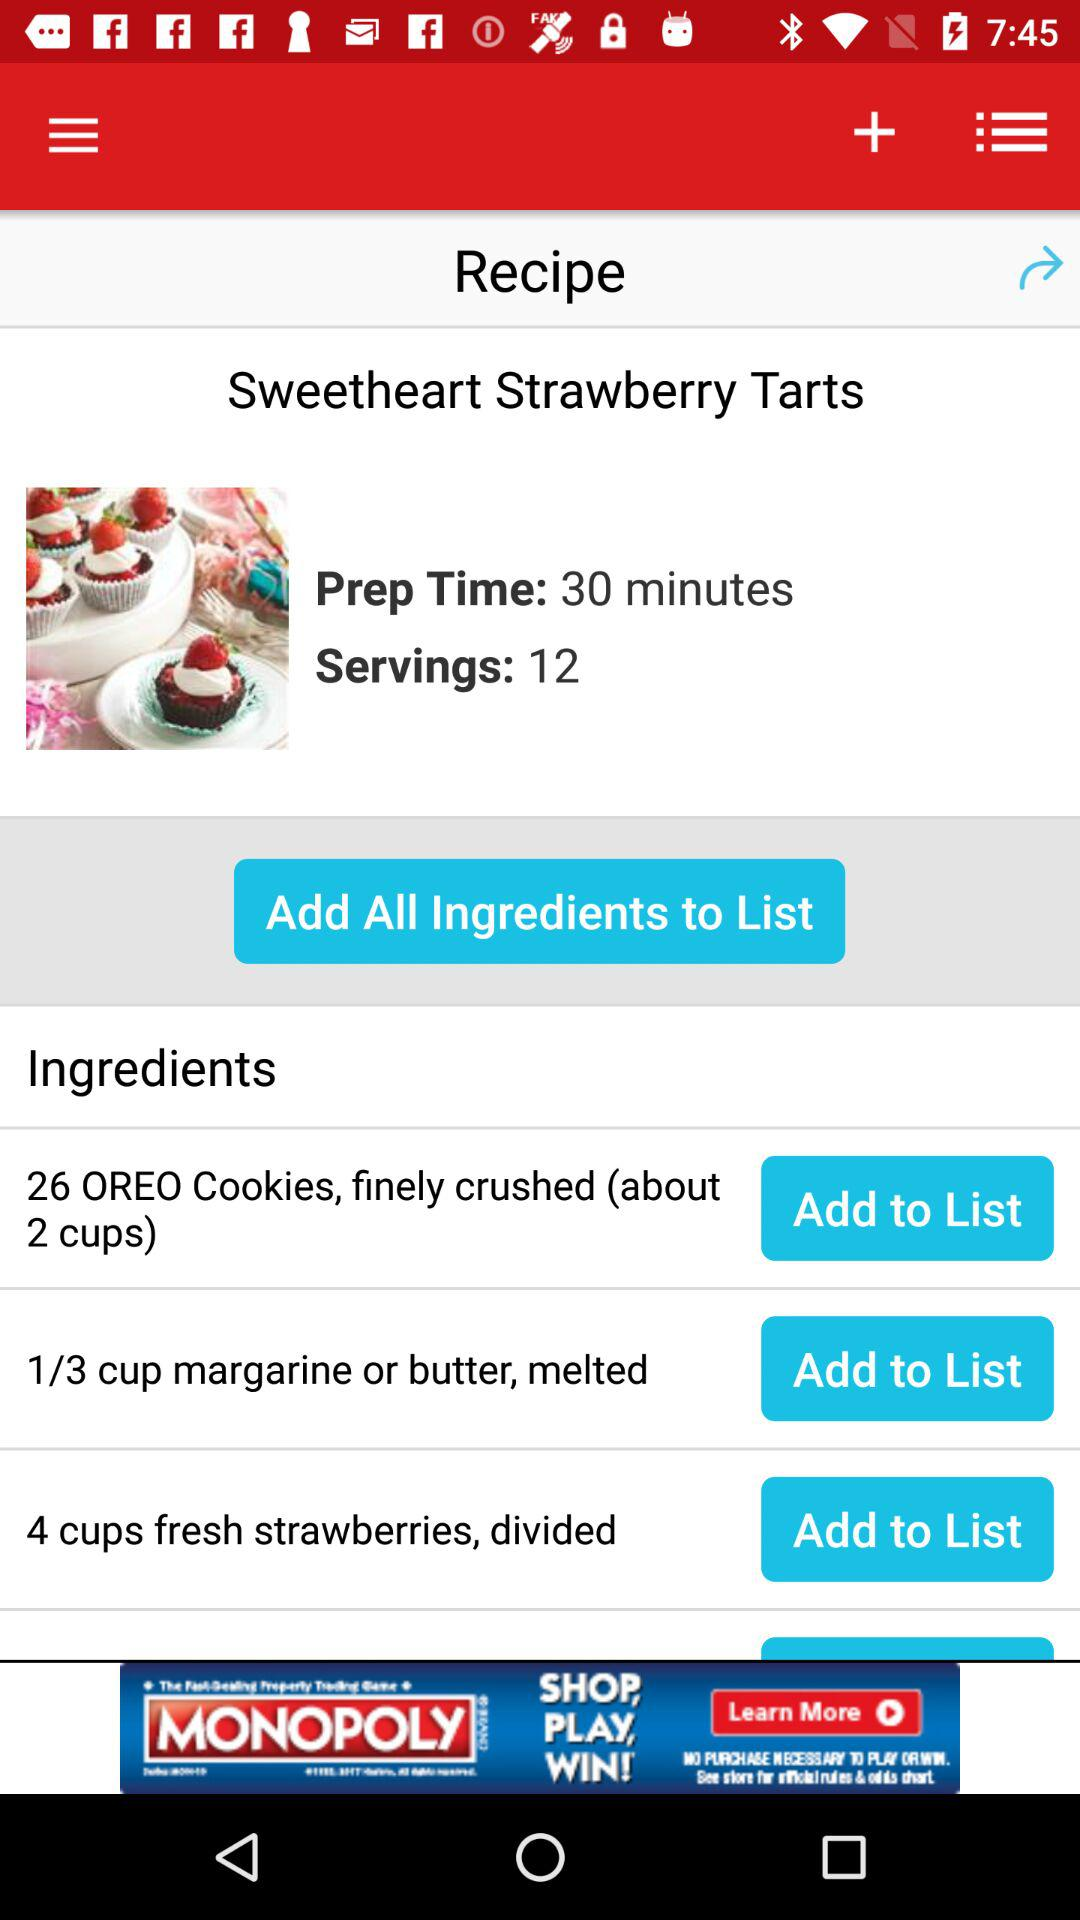What is the preparation time? The preparation time is 30 minutes. 